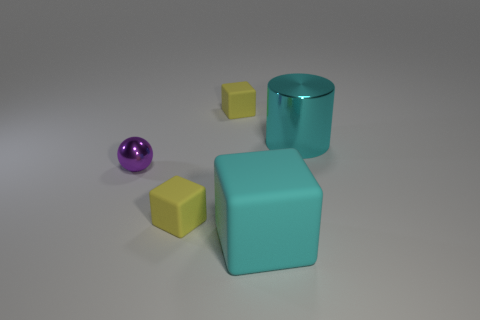Are there more cyan cylinders than small yellow matte blocks?
Ensure brevity in your answer.  No. There is a sphere that is made of the same material as the cylinder; what is its size?
Make the answer very short. Small. Does the cyan metallic object behind the tiny ball have the same size as the metallic thing that is to the left of the cyan block?
Offer a terse response. No. How many things are cubes in front of the purple ball or tiny objects?
Your response must be concise. 4. Are there fewer purple metallic objects than small yellow things?
Provide a succinct answer. Yes. There is a tiny thing on the left side of the yellow matte cube that is in front of the metal object that is on the right side of the purple shiny ball; what is its shape?
Keep it short and to the point. Sphere. There is a matte thing that is the same color as the big metallic cylinder; what shape is it?
Your answer should be compact. Cube. Are there any large brown rubber things?
Your response must be concise. No. Is the size of the cyan rubber thing the same as the yellow thing that is behind the tiny shiny sphere?
Provide a short and direct response. No. There is a small object behind the large cyan metallic object; is there a block in front of it?
Keep it short and to the point. Yes. 